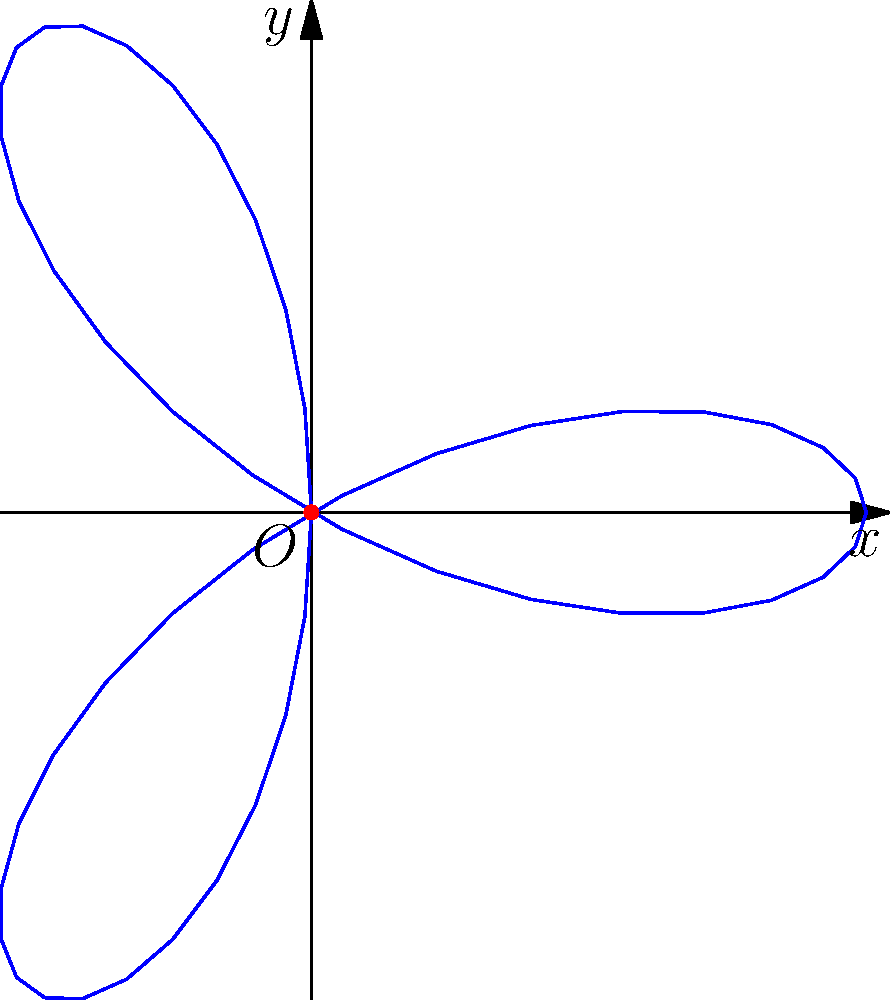In the spirit of Henri Heurtebise's poetic metaphors, consider a rose curve represented by the polar equation $r = 2\cos(3\theta)$. This curve forms a shape reminiscent of a three-petaled flower. Calculate the area enclosed by this poetic rose, expressing your answer in terms of $\pi$. To find the area enclosed by this rose curve, we'll follow these steps:

1) The general formula for the area enclosed by a polar curve is:
   $$A = \frac{1}{2}\int_{0}^{2\pi} r^2(\theta) d\theta$$

2) In our case, $r(\theta) = 2\cos(3\theta)$, so we need to calculate:
   $$A = \frac{1}{2}\int_{0}^{2\pi} [2\cos(3\theta)]^2 d\theta$$

3) Simplify the integrand:
   $$A = 2\int_{0}^{2\pi} \cos^2(3\theta) d\theta$$

4) Use the trigonometric identity $\cos^2(x) = \frac{1}{2}[1 + \cos(2x)]$:
   $$A = 2\int_{0}^{2\pi} \frac{1}{2}[1 + \cos(6\theta)] d\theta = \int_{0}^{2\pi} [1 + \cos(6\theta)] d\theta$$

5) Integrate:
   $$A = [\theta + \frac{1}{6}\sin(6\theta)]_{0}^{2\pi}$$

6) Evaluate the integral:
   $$A = [2\pi + \frac{1}{6}\sin(12\pi)] - [0 + \frac{1}{6}\sin(0)] = 2\pi$$

Thus, the area enclosed by this poetic rose curve is $2\pi$ square units.
Answer: $2\pi$ square units 